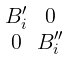Convert formula to latex. <formula><loc_0><loc_0><loc_500><loc_500>\begin{smallmatrix} B _ { i } ^ { \prime } & 0 \\ 0 & B _ { i } ^ { \prime \prime } \end{smallmatrix}</formula> 